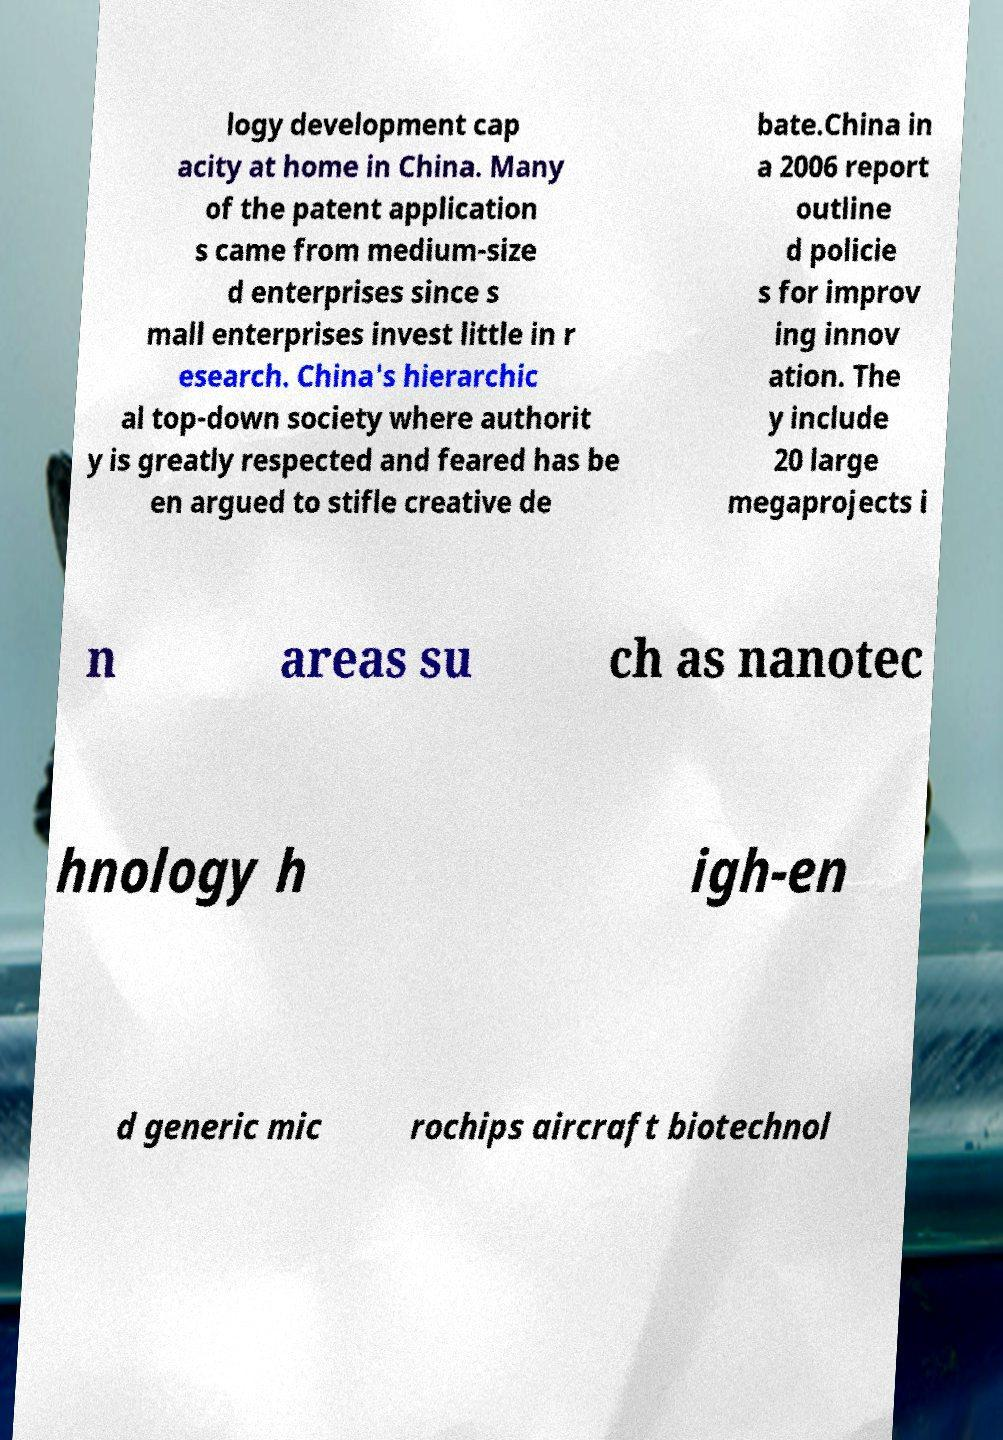Can you read and provide the text displayed in the image?This photo seems to have some interesting text. Can you extract and type it out for me? logy development cap acity at home in China. Many of the patent application s came from medium-size d enterprises since s mall enterprises invest little in r esearch. China's hierarchic al top-down society where authorit y is greatly respected and feared has be en argued to stifle creative de bate.China in a 2006 report outline d policie s for improv ing innov ation. The y include 20 large megaprojects i n areas su ch as nanotec hnology h igh-en d generic mic rochips aircraft biotechnol 